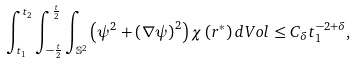<formula> <loc_0><loc_0><loc_500><loc_500>\int _ { t _ { 1 } } ^ { t _ { 2 } } \int _ { - \frac { t } { 2 } } ^ { \frac { t } { 2 } } \int _ { \mathbb { S } ^ { 2 } } \left ( \psi ^ { 2 } + \left ( \nabla \psi \right ) ^ { 2 } \right ) \chi \left ( r ^ { * } \right ) d V o l \leq C _ { \delta } t _ { 1 } ^ { - 2 + \delta } ,</formula> 